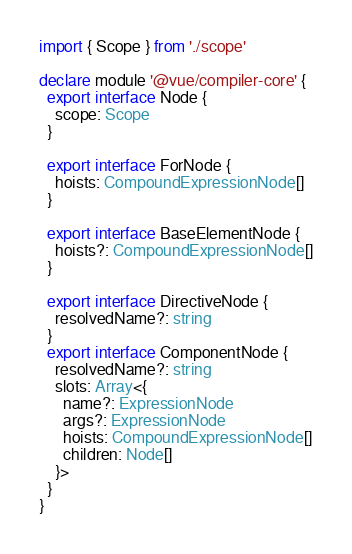Convert code to text. <code><loc_0><loc_0><loc_500><loc_500><_TypeScript_>import { Scope } from './scope'

declare module '@vue/compiler-core' {
  export interface Node {
    scope: Scope
  }

  export interface ForNode {
    hoists: CompoundExpressionNode[]
  }

  export interface BaseElementNode {
    hoists?: CompoundExpressionNode[]
  }

  export interface DirectiveNode {
    resolvedName?: string
  }
  export interface ComponentNode {
    resolvedName?: string
    slots: Array<{
      name?: ExpressionNode
      args?: ExpressionNode
      hoists: CompoundExpressionNode[]
      children: Node[]
    }>
  }
}
</code> 